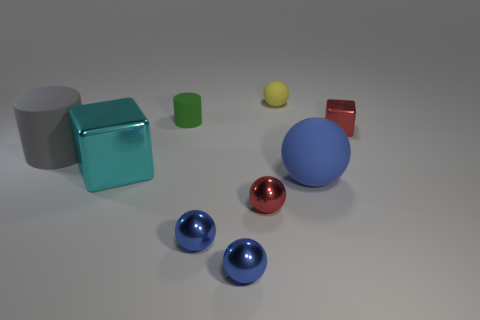How many small blocks are the same color as the small cylinder?
Your answer should be compact. 0. What size is the red metallic block?
Offer a terse response. Small. Does the gray matte thing have the same shape as the red metal thing that is behind the big gray matte thing?
Your answer should be very brief. No. There is a big sphere that is the same material as the yellow thing; what color is it?
Provide a succinct answer. Blue. There is a metal cube in front of the red metal cube; how big is it?
Your answer should be very brief. Large. Is the number of large gray matte cylinders on the left side of the tiny rubber cylinder less than the number of small brown matte cubes?
Offer a terse response. No. Is the big block the same color as the small metallic block?
Keep it short and to the point. No. Is there anything else that has the same shape as the yellow object?
Provide a succinct answer. Yes. Are there fewer blocks than tiny green cubes?
Offer a very short reply. No. There is a shiny block on the left side of the metal cube right of the small rubber cylinder; what color is it?
Your response must be concise. Cyan. 